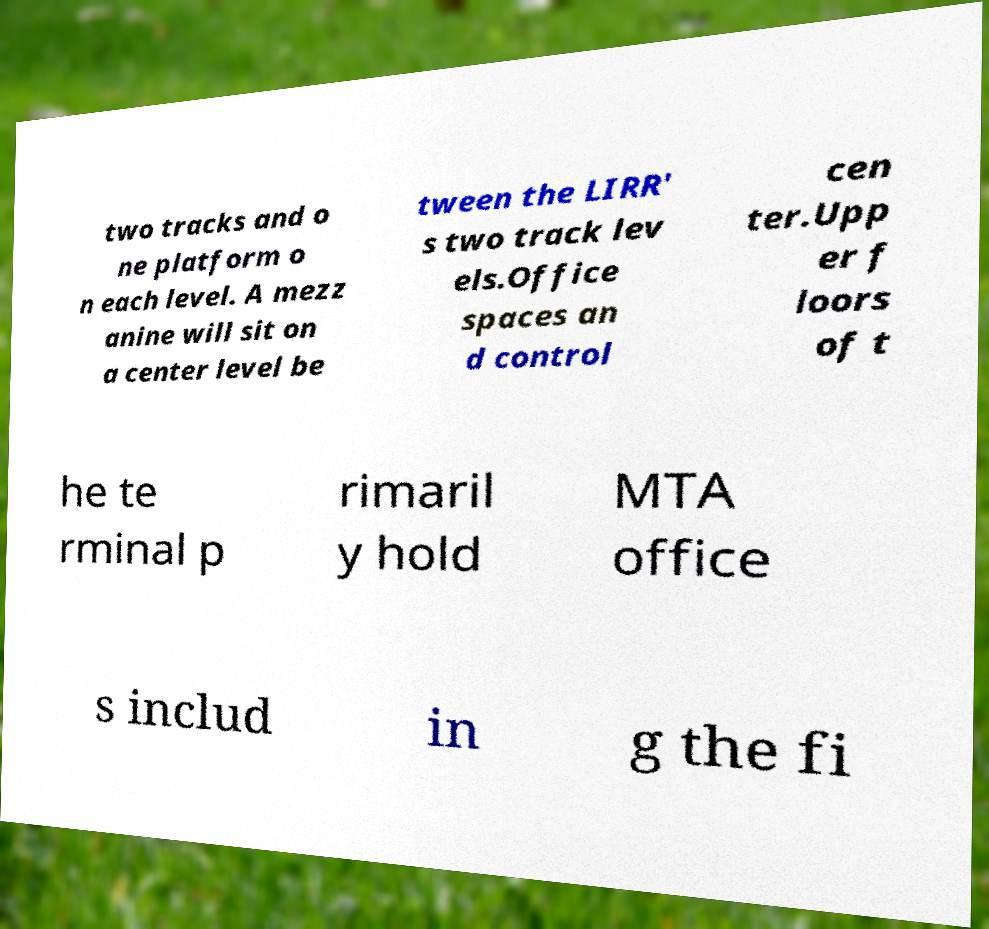What messages or text are displayed in this image? I need them in a readable, typed format. two tracks and o ne platform o n each level. A mezz anine will sit on a center level be tween the LIRR' s two track lev els.Office spaces an d control cen ter.Upp er f loors of t he te rminal p rimaril y hold MTA office s includ in g the fi 